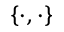Convert formula to latex. <formula><loc_0><loc_0><loc_500><loc_500>\{ \cdot , \cdot \}</formula> 